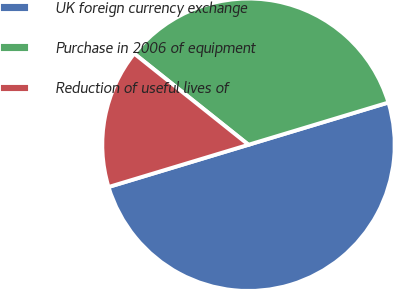Convert chart. <chart><loc_0><loc_0><loc_500><loc_500><pie_chart><fcel>UK foreign currency exchange<fcel>Purchase in 2006 of equipment<fcel>Reduction of useful lives of<nl><fcel>50.0%<fcel>34.62%<fcel>15.38%<nl></chart> 